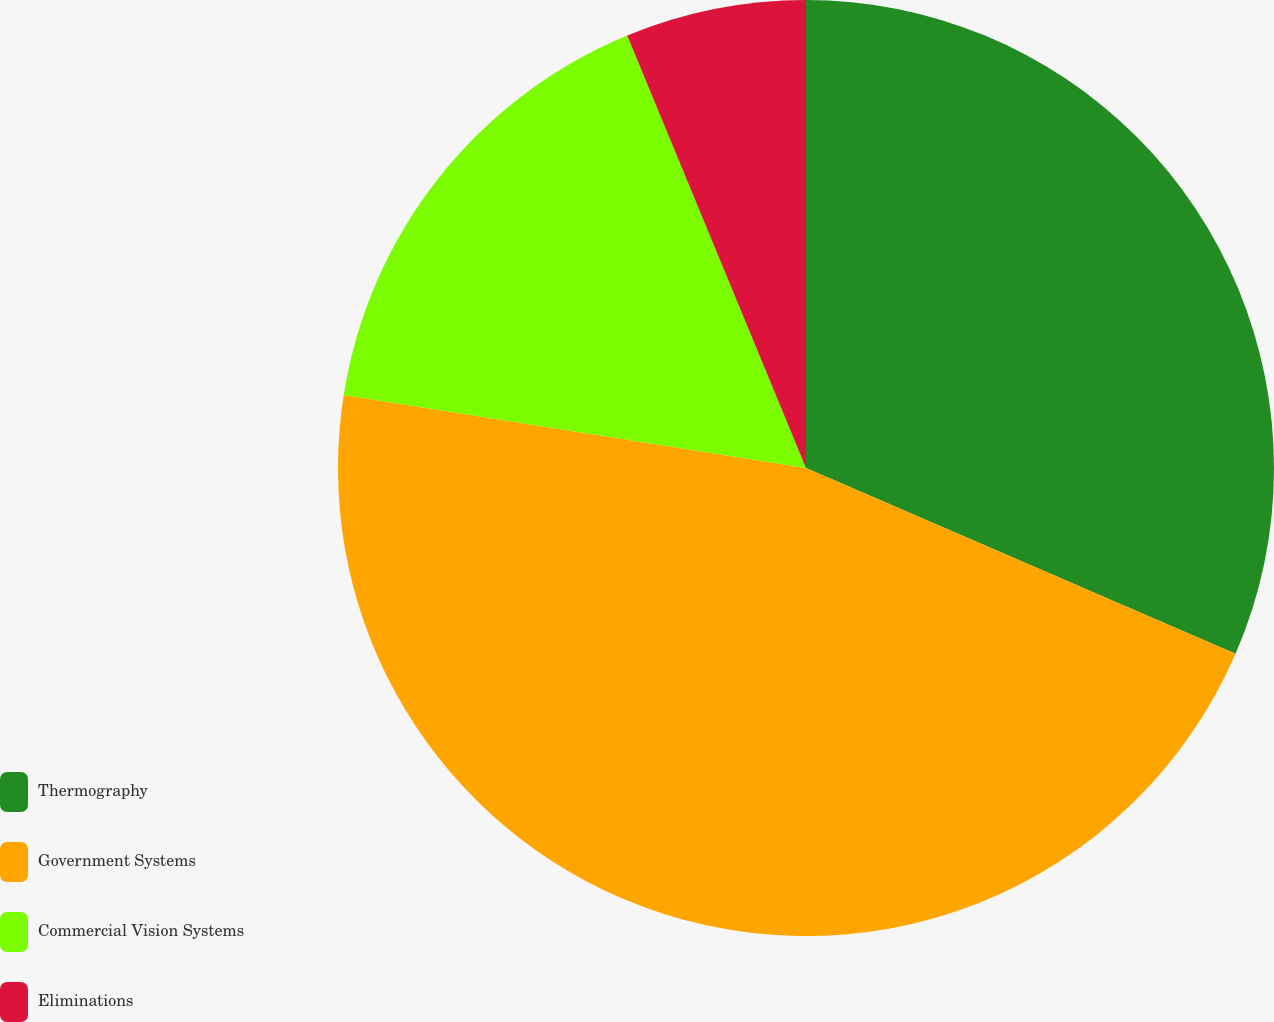Convert chart. <chart><loc_0><loc_0><loc_500><loc_500><pie_chart><fcel>Thermography<fcel>Government Systems<fcel>Commercial Vision Systems<fcel>Eliminations<nl><fcel>31.5%<fcel>45.99%<fcel>16.27%<fcel>6.24%<nl></chart> 